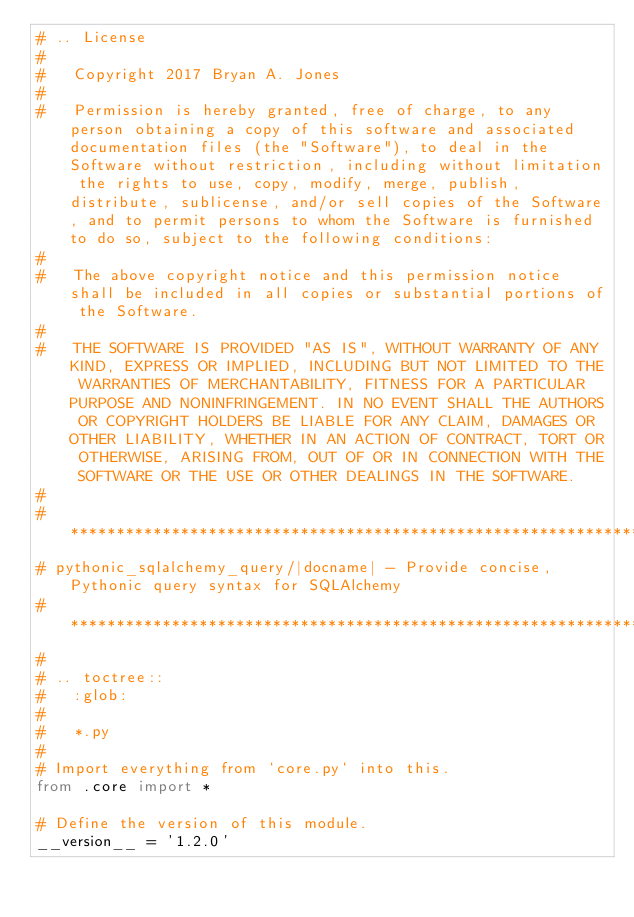Convert code to text. <code><loc_0><loc_0><loc_500><loc_500><_Python_># .. License
#
#   Copyright 2017 Bryan A. Jones
#
#   Permission is hereby granted, free of charge, to any person obtaining a copy of this software and associated documentation files (the "Software"), to deal in the Software without restriction, including without limitation the rights to use, copy, modify, merge, publish, distribute, sublicense, and/or sell copies of the Software, and to permit persons to whom the Software is furnished to do so, subject to the following conditions:
#
#   The above copyright notice and this permission notice shall be included in all copies or substantial portions of the Software.
#
#   THE SOFTWARE IS PROVIDED "AS IS", WITHOUT WARRANTY OF ANY KIND, EXPRESS OR IMPLIED, INCLUDING BUT NOT LIMITED TO THE WARRANTIES OF MERCHANTABILITY, FITNESS FOR A PARTICULAR PURPOSE AND NONINFRINGEMENT. IN NO EVENT SHALL THE AUTHORS OR COPYRIGHT HOLDERS BE LIABLE FOR ANY CLAIM, DAMAGES OR OTHER LIABILITY, WHETHER IN AN ACTION OF CONTRACT, TORT OR OTHERWISE, ARISING FROM, OUT OF OR IN CONNECTION WITH THE SOFTWARE OR THE USE OR OTHER DEALINGS IN THE SOFTWARE.
#
# *******************************************************************************************
# pythonic_sqlalchemy_query/|docname| - Provide concise, Pythonic query syntax for SQLAlchemy
# *******************************************************************************************
#
# .. toctree::
#   :glob:
#
#   *.py
#
# Import everything from `core.py` into this.
from .core import *

# Define the version of this module.
__version__ = '1.2.0'
</code> 